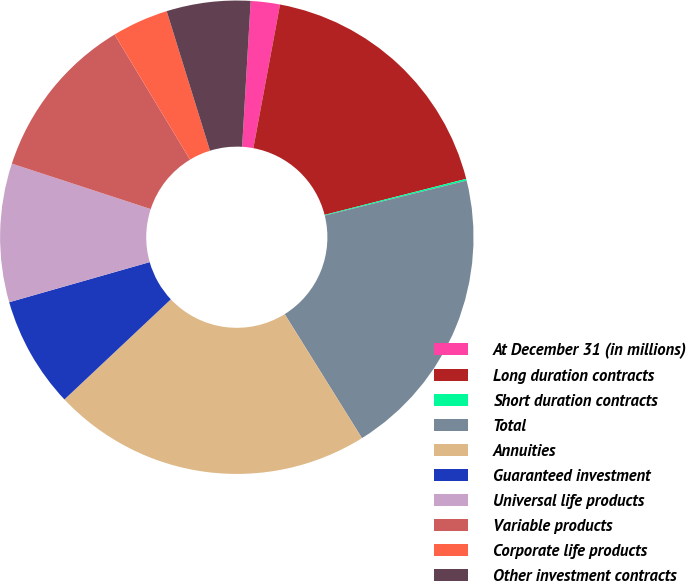Convert chart. <chart><loc_0><loc_0><loc_500><loc_500><pie_chart><fcel>At December 31 (in millions)<fcel>Long duration contracts<fcel>Short duration contracts<fcel>Total<fcel>Annuities<fcel>Guaranteed investment<fcel>Universal life products<fcel>Variable products<fcel>Corporate life products<fcel>Other investment contracts<nl><fcel>1.99%<fcel>18.11%<fcel>0.12%<fcel>19.98%<fcel>21.85%<fcel>7.59%<fcel>9.46%<fcel>11.33%<fcel>3.85%<fcel>5.72%<nl></chart> 